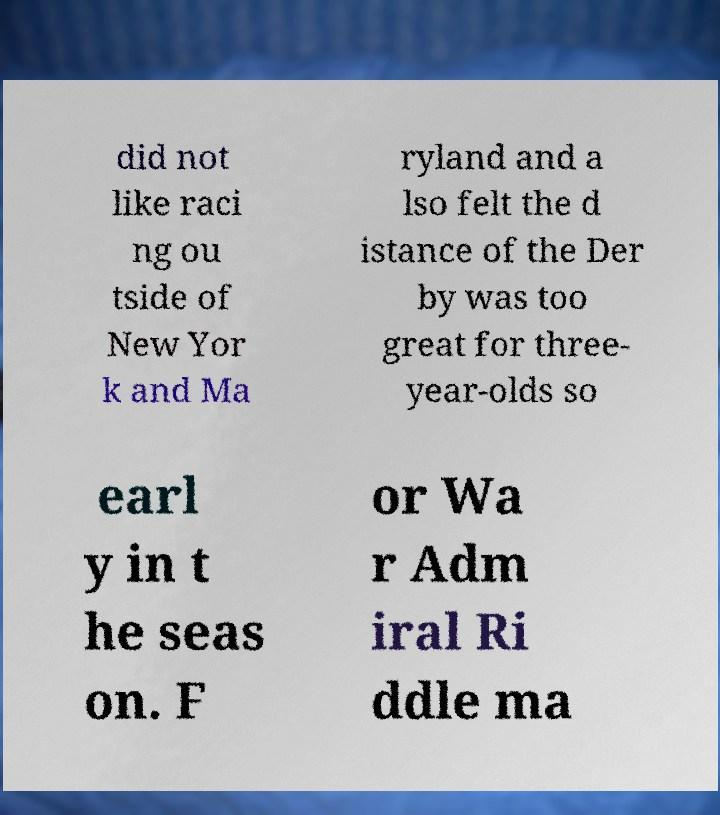I need the written content from this picture converted into text. Can you do that? did not like raci ng ou tside of New Yor k and Ma ryland and a lso felt the d istance of the Der by was too great for three- year-olds so earl y in t he seas on. F or Wa r Adm iral Ri ddle ma 